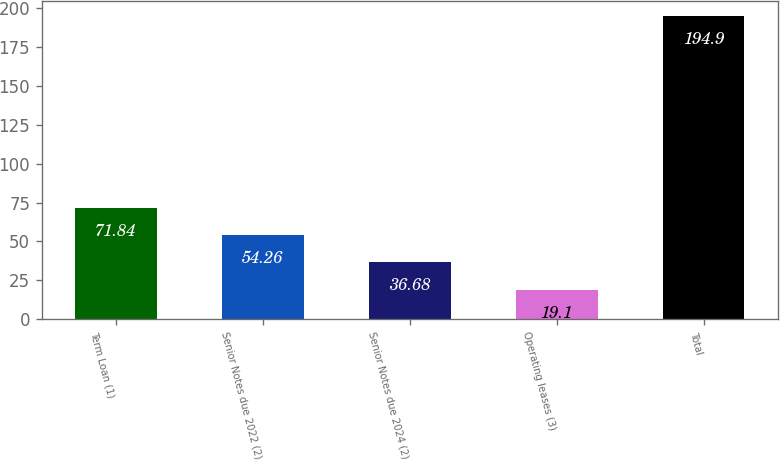<chart> <loc_0><loc_0><loc_500><loc_500><bar_chart><fcel>Term Loan (1)<fcel>Senior Notes due 2022 (2)<fcel>Senior Notes due 2024 (2)<fcel>Operating leases (3)<fcel>Total<nl><fcel>71.84<fcel>54.26<fcel>36.68<fcel>19.1<fcel>194.9<nl></chart> 